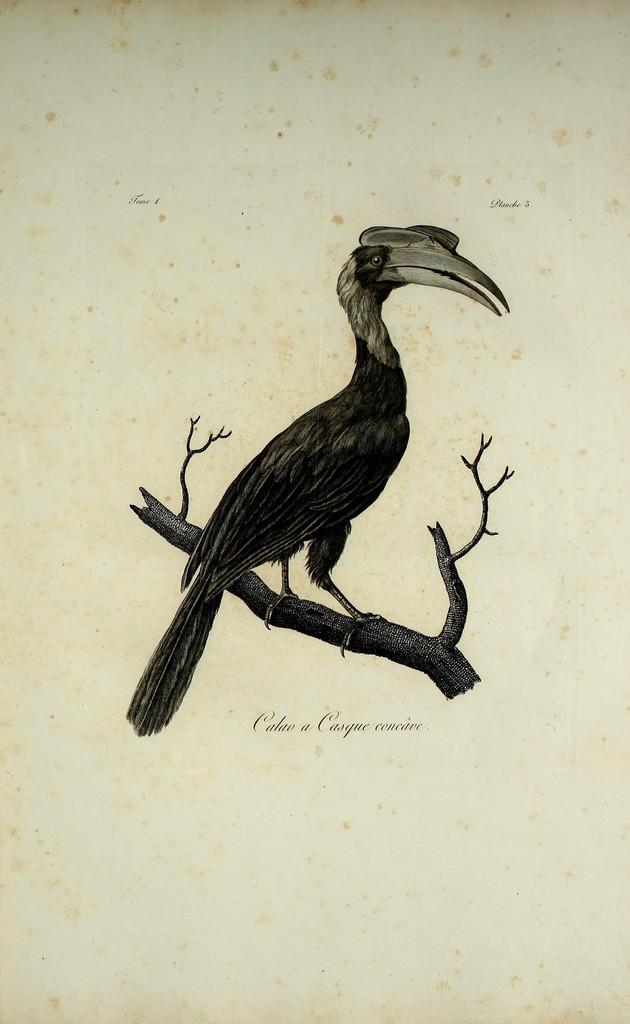What type of animal can be seen in the image? There is a bird in the image. Where is the bird located? The bird is standing on a branch. What is written under the branch and bird? There is no information provided about the writing in the image. How many pockets does the bird have in the image? There is no mention of pockets in the image, as birds do not have pockets. 